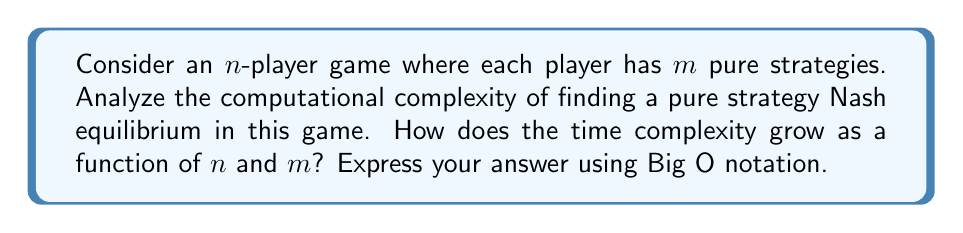Provide a solution to this math problem. To analyze the computational complexity of finding a pure strategy Nash equilibrium in an n-player game, we need to consider the following steps:

1. First, let's understand what a pure strategy Nash equilibrium is:
   A pure strategy Nash equilibrium is a set of strategies, one for each player, such that no player can unilaterally change their strategy to improve their payoff.

2. To find a pure strategy Nash equilibrium, we need to check all possible combinations of pure strategies:
   - There are $n$ players
   - Each player has $m$ pure strategies
   - Total number of strategy combinations: $m^n$

3. For each combination, we need to check if it's a Nash equilibrium:
   - For each player (n times):
     - Check if changing to any other strategy (m-1 times) improves their payoff
   - This results in $n(m-1)$ checks per combination

4. Total number of operations:
   $$(m^n) \cdot (n(m-1))$$

5. Simplifying:
   $$O(nm^{n+1})$$

This analysis assumes that checking a player's payoff for a given strategy combination is constant time, which is reasonable for most game representations.

The time complexity grows exponentially with the number of players (n) and polynomially with the number of strategies per player (m). This makes the problem intractable for large values of n or m, placing it in the class of NEXP-complete problems (Nondeterministic Exponential Time).
Answer: $O(nm^{n+1})$ 